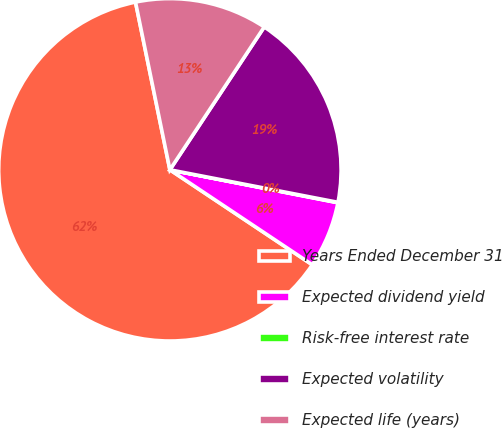Convert chart. <chart><loc_0><loc_0><loc_500><loc_500><pie_chart><fcel>Years Ended December 31<fcel>Expected dividend yield<fcel>Risk-free interest rate<fcel>Expected volatility<fcel>Expected life (years)<nl><fcel>62.42%<fcel>6.28%<fcel>0.04%<fcel>18.75%<fcel>12.51%<nl></chart> 